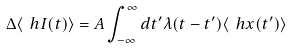Convert formula to latex. <formula><loc_0><loc_0><loc_500><loc_500>\Delta \langle \ h I ( t ) \rangle = A \int _ { - \infty } ^ { \infty } d t ^ { \prime } \lambda ( t - t ^ { \prime } ) \langle \ h x ( t ^ { \prime } ) \rangle</formula> 